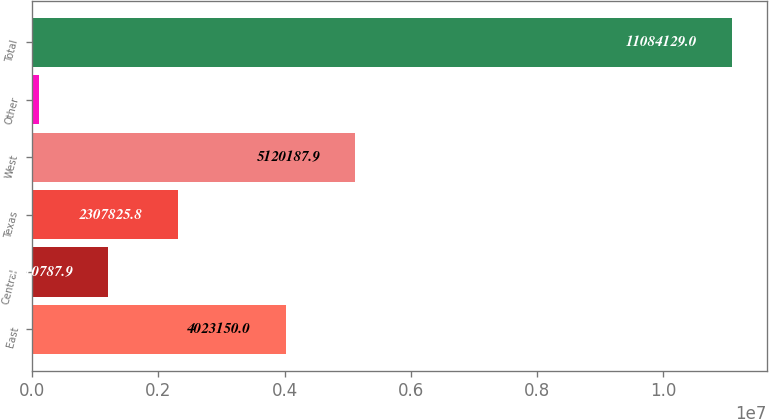Convert chart. <chart><loc_0><loc_0><loc_500><loc_500><bar_chart><fcel>East<fcel>Central<fcel>Texas<fcel>West<fcel>Other<fcel>Total<nl><fcel>4.02315e+06<fcel>1.21079e+06<fcel>2.30783e+06<fcel>5.12019e+06<fcel>113750<fcel>1.10841e+07<nl></chart> 